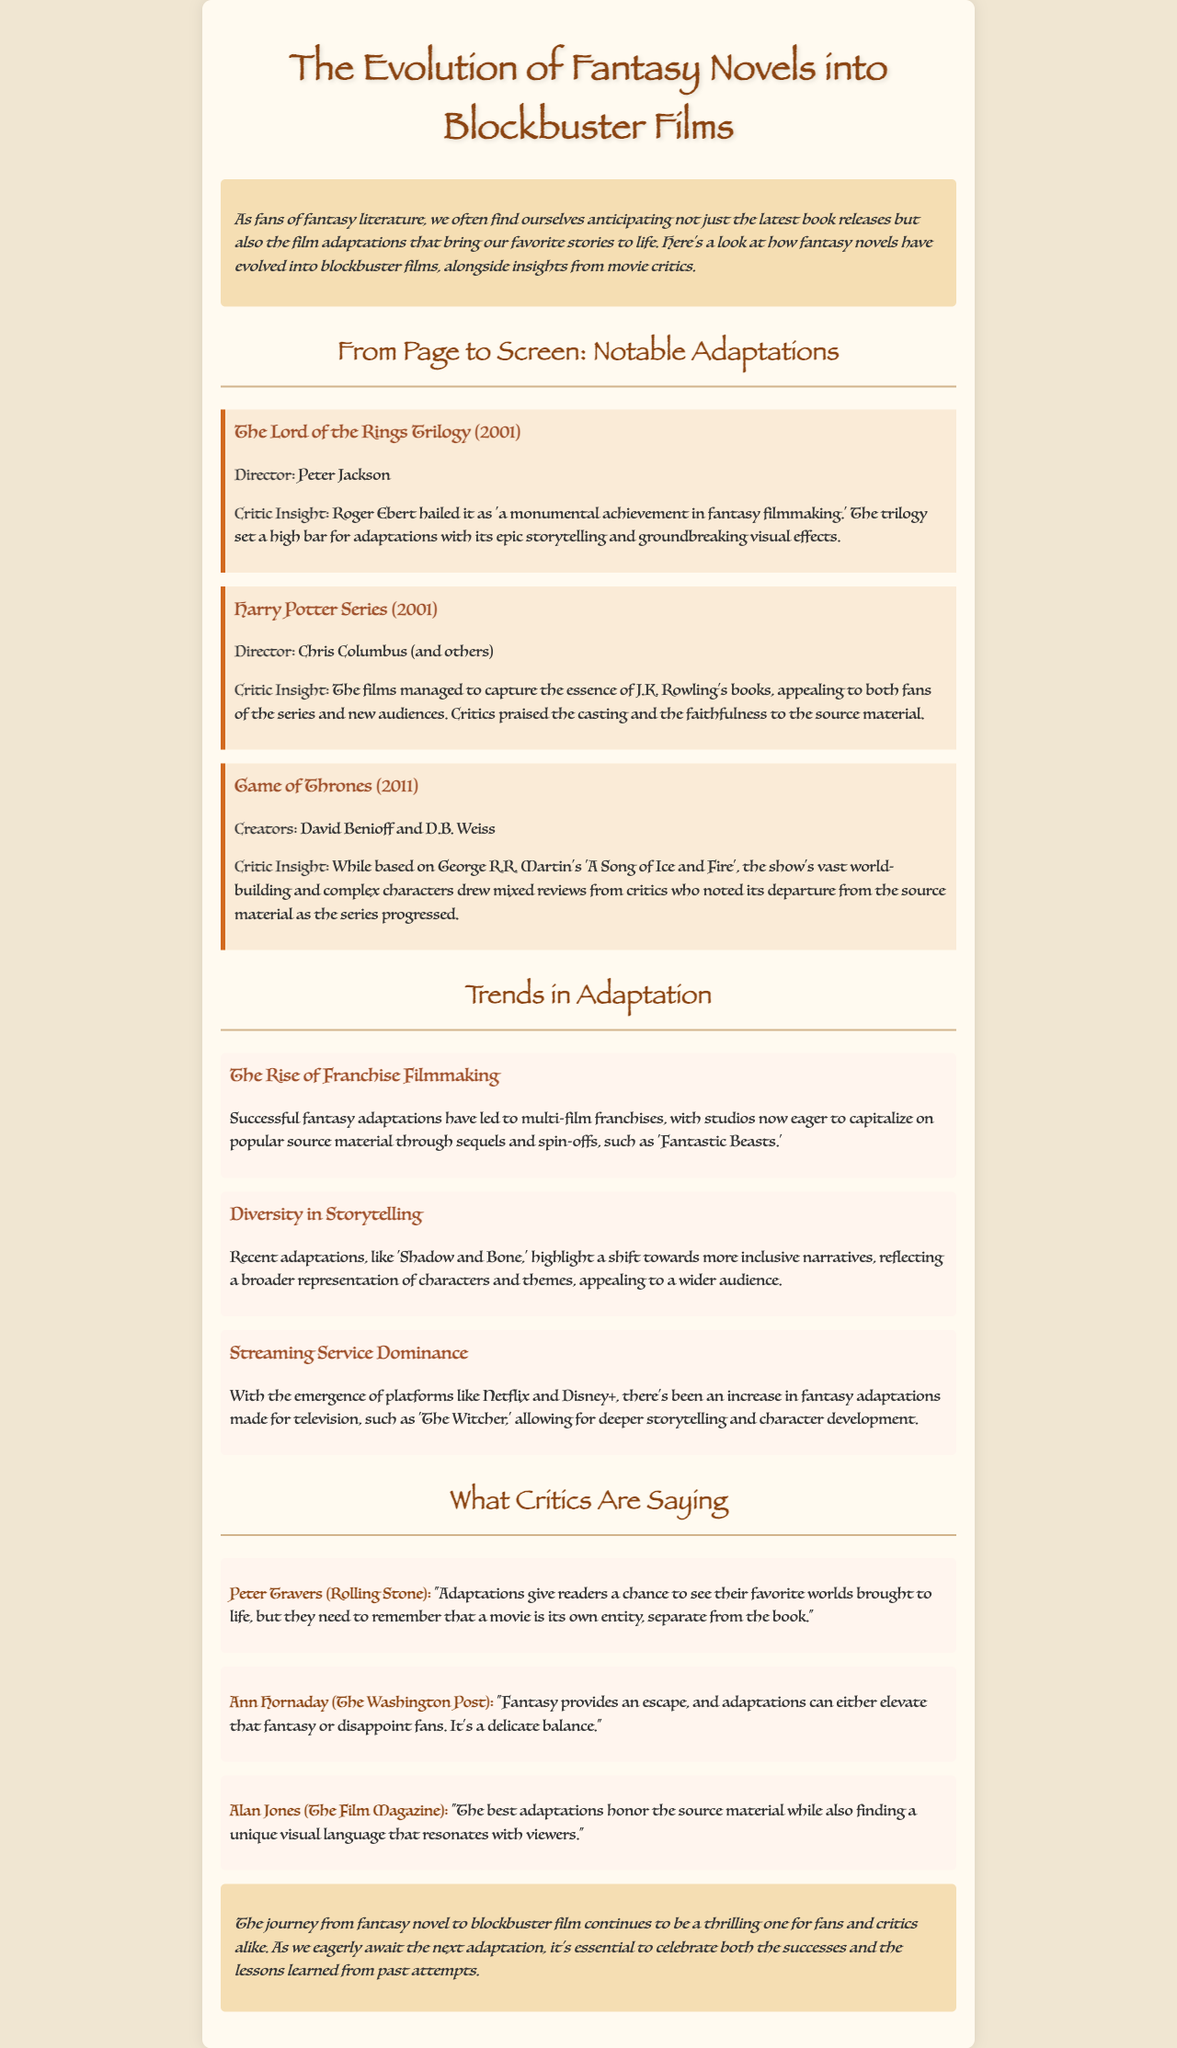What is the title of the newsletter? The title of the newsletter is stated at the top of the document.
Answer: The Evolution of Fantasy Novels into Blockbuster Films Who directed The Lord of the Rings Trilogy? The document provides the director's name for this adaptation in the notable adaptations section.
Answer: Peter Jackson What year was the Harry Potter Series released? The release year for the Harry Potter Series is mentioned next to the title in the adaptations section.
Answer: 2001 Which adaptation is noted for its mixed reviews due to departure from the source material? The document discusses the reception of Game of Thrones in terms of critics' reviews.
Answer: Game of Thrones What trend in adaptation emphasizes inclusive narratives? The trends section discusses various new directions in fantasy adaptations, specifically the focus on diversity.
Answer: Diversity in Storytelling How many notable adaptations are listed in the document? The document lists three adaptations in the notable adaptations section.
Answer: Three Which critic stated that adaptations should honor the source material while finding a unique visual language? This information is found in the critics' quotes section of the document.
Answer: Alan Jones What is highlighted by the trend regarding streaming services? The trends section specifically discusses the impact of streaming services on fantasy adaptations.
Answer: Streaming Service Dominance What kind of balance do adaptations need to strike according to a critic? The reasoning is derived from Ann Hornaday's quote about the delicate nature of balancing fantasy and adaptation success.
Answer: Delicate balance 